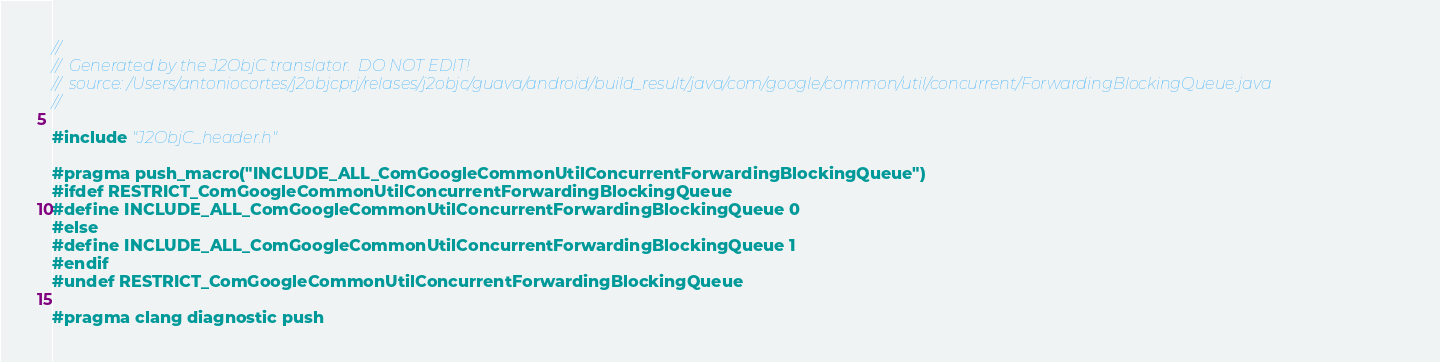<code> <loc_0><loc_0><loc_500><loc_500><_C_>//
//  Generated by the J2ObjC translator.  DO NOT EDIT!
//  source: /Users/antoniocortes/j2objcprj/relases/j2objc/guava/android/build_result/java/com/google/common/util/concurrent/ForwardingBlockingQueue.java
//

#include "J2ObjC_header.h"

#pragma push_macro("INCLUDE_ALL_ComGoogleCommonUtilConcurrentForwardingBlockingQueue")
#ifdef RESTRICT_ComGoogleCommonUtilConcurrentForwardingBlockingQueue
#define INCLUDE_ALL_ComGoogleCommonUtilConcurrentForwardingBlockingQueue 0
#else
#define INCLUDE_ALL_ComGoogleCommonUtilConcurrentForwardingBlockingQueue 1
#endif
#undef RESTRICT_ComGoogleCommonUtilConcurrentForwardingBlockingQueue

#pragma clang diagnostic push</code> 